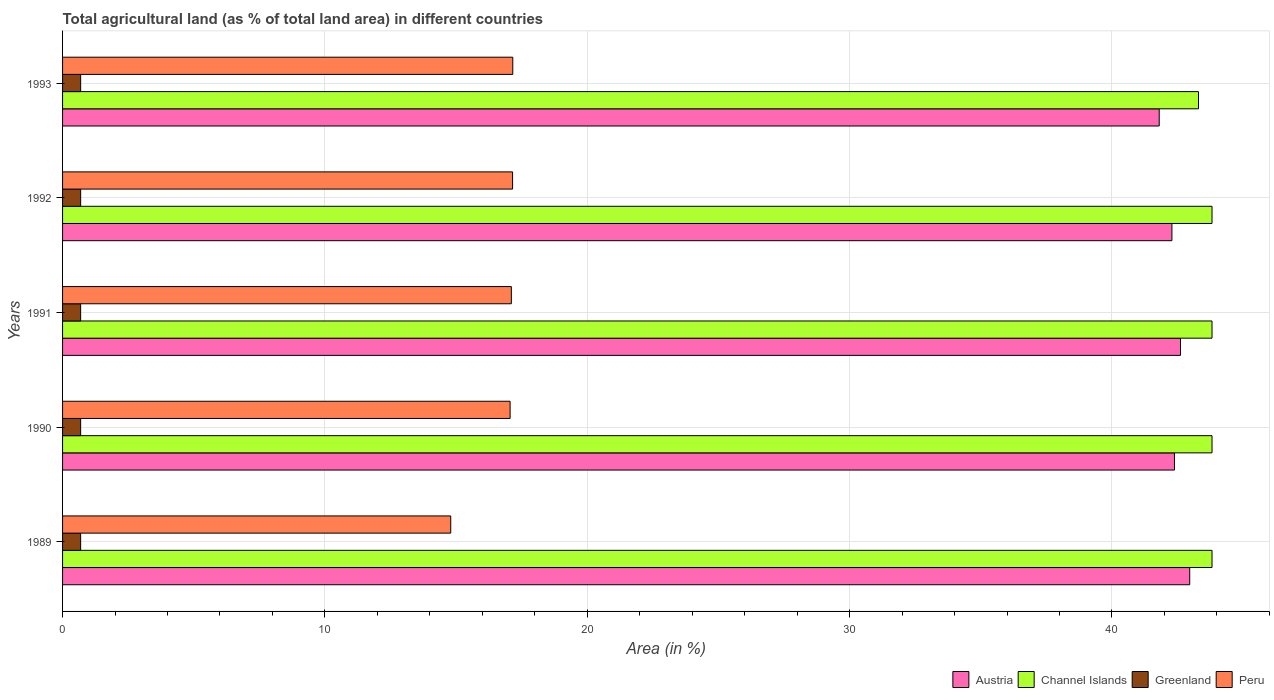How many different coloured bars are there?
Offer a very short reply. 4. How many bars are there on the 3rd tick from the top?
Your answer should be very brief. 4. What is the label of the 4th group of bars from the top?
Provide a short and direct response. 1990. What is the percentage of agricultural land in Austria in 1990?
Your answer should be compact. 42.38. Across all years, what is the maximum percentage of agricultural land in Peru?
Keep it short and to the point. 17.16. Across all years, what is the minimum percentage of agricultural land in Greenland?
Your answer should be very brief. 0.69. In which year was the percentage of agricultural land in Peru minimum?
Provide a short and direct response. 1989. What is the total percentage of agricultural land in Greenland in the graph?
Your answer should be very brief. 3.45. What is the difference between the percentage of agricultural land in Austria in 1991 and that in 1993?
Ensure brevity in your answer.  0.81. What is the difference between the percentage of agricultural land in Greenland in 1990 and the percentage of agricultural land in Austria in 1989?
Offer a terse response. -42.28. What is the average percentage of agricultural land in Greenland per year?
Your answer should be compact. 0.69. In the year 1991, what is the difference between the percentage of agricultural land in Austria and percentage of agricultural land in Channel Islands?
Make the answer very short. -1.2. What is the ratio of the percentage of agricultural land in Greenland in 1991 to that in 1992?
Your response must be concise. 1. What is the difference between the highest and the second highest percentage of agricultural land in Austria?
Keep it short and to the point. 0.35. What is the difference between the highest and the lowest percentage of agricultural land in Channel Islands?
Give a very brief answer. 0.52. Is the sum of the percentage of agricultural land in Austria in 1989 and 1990 greater than the maximum percentage of agricultural land in Peru across all years?
Make the answer very short. Yes. What does the 3rd bar from the top in 1993 represents?
Your response must be concise. Channel Islands. What does the 1st bar from the bottom in 1993 represents?
Your answer should be compact. Austria. Is it the case that in every year, the sum of the percentage of agricultural land in Channel Islands and percentage of agricultural land in Greenland is greater than the percentage of agricultural land in Peru?
Your answer should be compact. Yes. How many bars are there?
Your answer should be compact. 20. How many years are there in the graph?
Your answer should be very brief. 5. Does the graph contain any zero values?
Your answer should be compact. No. Does the graph contain grids?
Your response must be concise. Yes. How many legend labels are there?
Provide a short and direct response. 4. How are the legend labels stacked?
Provide a short and direct response. Horizontal. What is the title of the graph?
Your answer should be compact. Total agricultural land (as % of total land area) in different countries. What is the label or title of the X-axis?
Offer a terse response. Area (in %). What is the label or title of the Y-axis?
Offer a terse response. Years. What is the Area (in %) of Austria in 1989?
Provide a succinct answer. 42.96. What is the Area (in %) of Channel Islands in 1989?
Your response must be concise. 43.81. What is the Area (in %) of Greenland in 1989?
Make the answer very short. 0.69. What is the Area (in %) of Peru in 1989?
Provide a succinct answer. 14.8. What is the Area (in %) of Austria in 1990?
Keep it short and to the point. 42.38. What is the Area (in %) of Channel Islands in 1990?
Give a very brief answer. 43.81. What is the Area (in %) in Greenland in 1990?
Your answer should be very brief. 0.69. What is the Area (in %) in Peru in 1990?
Make the answer very short. 17.06. What is the Area (in %) in Austria in 1991?
Keep it short and to the point. 42.61. What is the Area (in %) in Channel Islands in 1991?
Give a very brief answer. 43.81. What is the Area (in %) of Greenland in 1991?
Keep it short and to the point. 0.69. What is the Area (in %) of Peru in 1991?
Offer a terse response. 17.11. What is the Area (in %) of Austria in 1992?
Keep it short and to the point. 42.29. What is the Area (in %) of Channel Islands in 1992?
Your answer should be compact. 43.81. What is the Area (in %) in Greenland in 1992?
Provide a short and direct response. 0.69. What is the Area (in %) of Peru in 1992?
Your answer should be very brief. 17.15. What is the Area (in %) of Austria in 1993?
Offer a terse response. 41.8. What is the Area (in %) in Channel Islands in 1993?
Provide a short and direct response. 43.3. What is the Area (in %) in Greenland in 1993?
Offer a terse response. 0.69. What is the Area (in %) in Peru in 1993?
Make the answer very short. 17.16. Across all years, what is the maximum Area (in %) of Austria?
Offer a terse response. 42.96. Across all years, what is the maximum Area (in %) of Channel Islands?
Give a very brief answer. 43.81. Across all years, what is the maximum Area (in %) of Greenland?
Give a very brief answer. 0.69. Across all years, what is the maximum Area (in %) of Peru?
Make the answer very short. 17.16. Across all years, what is the minimum Area (in %) in Austria?
Offer a very short reply. 41.8. Across all years, what is the minimum Area (in %) in Channel Islands?
Provide a succinct answer. 43.3. Across all years, what is the minimum Area (in %) of Greenland?
Ensure brevity in your answer.  0.69. Across all years, what is the minimum Area (in %) in Peru?
Offer a terse response. 14.8. What is the total Area (in %) in Austria in the graph?
Provide a short and direct response. 212.05. What is the total Area (in %) of Channel Islands in the graph?
Provide a succinct answer. 218.56. What is the total Area (in %) in Greenland in the graph?
Give a very brief answer. 3.45. What is the total Area (in %) of Peru in the graph?
Make the answer very short. 83.28. What is the difference between the Area (in %) in Austria in 1989 and that in 1990?
Ensure brevity in your answer.  0.58. What is the difference between the Area (in %) of Channel Islands in 1989 and that in 1990?
Keep it short and to the point. 0. What is the difference between the Area (in %) of Greenland in 1989 and that in 1990?
Give a very brief answer. -0. What is the difference between the Area (in %) in Peru in 1989 and that in 1990?
Offer a very short reply. -2.26. What is the difference between the Area (in %) of Austria in 1989 and that in 1991?
Offer a terse response. 0.35. What is the difference between the Area (in %) of Greenland in 1989 and that in 1991?
Ensure brevity in your answer.  -0. What is the difference between the Area (in %) of Peru in 1989 and that in 1991?
Your answer should be very brief. -2.31. What is the difference between the Area (in %) of Austria in 1989 and that in 1992?
Your response must be concise. 0.68. What is the difference between the Area (in %) in Greenland in 1989 and that in 1992?
Provide a short and direct response. -0. What is the difference between the Area (in %) of Peru in 1989 and that in 1992?
Your response must be concise. -2.36. What is the difference between the Area (in %) in Austria in 1989 and that in 1993?
Keep it short and to the point. 1.16. What is the difference between the Area (in %) in Channel Islands in 1989 and that in 1993?
Offer a very short reply. 0.52. What is the difference between the Area (in %) of Greenland in 1989 and that in 1993?
Make the answer very short. -0. What is the difference between the Area (in %) of Peru in 1989 and that in 1993?
Your response must be concise. -2.36. What is the difference between the Area (in %) in Austria in 1990 and that in 1991?
Your answer should be compact. -0.23. What is the difference between the Area (in %) of Peru in 1990 and that in 1991?
Provide a succinct answer. -0.05. What is the difference between the Area (in %) in Austria in 1990 and that in 1992?
Offer a terse response. 0.1. What is the difference between the Area (in %) in Channel Islands in 1990 and that in 1992?
Your answer should be very brief. 0. What is the difference between the Area (in %) of Greenland in 1990 and that in 1992?
Provide a short and direct response. -0. What is the difference between the Area (in %) in Peru in 1990 and that in 1992?
Offer a terse response. -0.09. What is the difference between the Area (in %) in Austria in 1990 and that in 1993?
Keep it short and to the point. 0.58. What is the difference between the Area (in %) in Channel Islands in 1990 and that in 1993?
Your response must be concise. 0.52. What is the difference between the Area (in %) of Greenland in 1990 and that in 1993?
Make the answer very short. -0. What is the difference between the Area (in %) of Peru in 1990 and that in 1993?
Make the answer very short. -0.1. What is the difference between the Area (in %) in Austria in 1991 and that in 1992?
Make the answer very short. 0.33. What is the difference between the Area (in %) in Greenland in 1991 and that in 1992?
Offer a very short reply. -0. What is the difference between the Area (in %) of Peru in 1991 and that in 1992?
Your answer should be very brief. -0.05. What is the difference between the Area (in %) of Austria in 1991 and that in 1993?
Your answer should be very brief. 0.81. What is the difference between the Area (in %) in Channel Islands in 1991 and that in 1993?
Provide a short and direct response. 0.52. What is the difference between the Area (in %) in Greenland in 1991 and that in 1993?
Provide a succinct answer. -0. What is the difference between the Area (in %) of Peru in 1991 and that in 1993?
Provide a short and direct response. -0.05. What is the difference between the Area (in %) in Austria in 1992 and that in 1993?
Offer a very short reply. 0.48. What is the difference between the Area (in %) in Channel Islands in 1992 and that in 1993?
Provide a succinct answer. 0.52. What is the difference between the Area (in %) of Greenland in 1992 and that in 1993?
Keep it short and to the point. 0. What is the difference between the Area (in %) in Peru in 1992 and that in 1993?
Offer a very short reply. -0.01. What is the difference between the Area (in %) in Austria in 1989 and the Area (in %) in Channel Islands in 1990?
Your answer should be compact. -0.85. What is the difference between the Area (in %) in Austria in 1989 and the Area (in %) in Greenland in 1990?
Offer a terse response. 42.28. What is the difference between the Area (in %) in Austria in 1989 and the Area (in %) in Peru in 1990?
Make the answer very short. 25.91. What is the difference between the Area (in %) of Channel Islands in 1989 and the Area (in %) of Greenland in 1990?
Make the answer very short. 43.13. What is the difference between the Area (in %) in Channel Islands in 1989 and the Area (in %) in Peru in 1990?
Keep it short and to the point. 26.76. What is the difference between the Area (in %) in Greenland in 1989 and the Area (in %) in Peru in 1990?
Offer a terse response. -16.37. What is the difference between the Area (in %) of Austria in 1989 and the Area (in %) of Channel Islands in 1991?
Ensure brevity in your answer.  -0.85. What is the difference between the Area (in %) of Austria in 1989 and the Area (in %) of Greenland in 1991?
Provide a succinct answer. 42.28. What is the difference between the Area (in %) of Austria in 1989 and the Area (in %) of Peru in 1991?
Your response must be concise. 25.86. What is the difference between the Area (in %) of Channel Islands in 1989 and the Area (in %) of Greenland in 1991?
Keep it short and to the point. 43.13. What is the difference between the Area (in %) in Channel Islands in 1989 and the Area (in %) in Peru in 1991?
Make the answer very short. 26.71. What is the difference between the Area (in %) of Greenland in 1989 and the Area (in %) of Peru in 1991?
Provide a short and direct response. -16.42. What is the difference between the Area (in %) of Austria in 1989 and the Area (in %) of Channel Islands in 1992?
Provide a succinct answer. -0.85. What is the difference between the Area (in %) of Austria in 1989 and the Area (in %) of Greenland in 1992?
Offer a terse response. 42.27. What is the difference between the Area (in %) in Austria in 1989 and the Area (in %) in Peru in 1992?
Your response must be concise. 25.81. What is the difference between the Area (in %) of Channel Islands in 1989 and the Area (in %) of Greenland in 1992?
Your response must be concise. 43.12. What is the difference between the Area (in %) of Channel Islands in 1989 and the Area (in %) of Peru in 1992?
Offer a very short reply. 26.66. What is the difference between the Area (in %) of Greenland in 1989 and the Area (in %) of Peru in 1992?
Your response must be concise. -16.46. What is the difference between the Area (in %) of Austria in 1989 and the Area (in %) of Channel Islands in 1993?
Offer a terse response. -0.33. What is the difference between the Area (in %) of Austria in 1989 and the Area (in %) of Greenland in 1993?
Provide a succinct answer. 42.27. What is the difference between the Area (in %) in Austria in 1989 and the Area (in %) in Peru in 1993?
Make the answer very short. 25.8. What is the difference between the Area (in %) in Channel Islands in 1989 and the Area (in %) in Greenland in 1993?
Provide a short and direct response. 43.12. What is the difference between the Area (in %) of Channel Islands in 1989 and the Area (in %) of Peru in 1993?
Your answer should be very brief. 26.65. What is the difference between the Area (in %) in Greenland in 1989 and the Area (in %) in Peru in 1993?
Give a very brief answer. -16.47. What is the difference between the Area (in %) of Austria in 1990 and the Area (in %) of Channel Islands in 1991?
Provide a succinct answer. -1.43. What is the difference between the Area (in %) in Austria in 1990 and the Area (in %) in Greenland in 1991?
Provide a succinct answer. 41.69. What is the difference between the Area (in %) in Austria in 1990 and the Area (in %) in Peru in 1991?
Give a very brief answer. 25.28. What is the difference between the Area (in %) in Channel Islands in 1990 and the Area (in %) in Greenland in 1991?
Ensure brevity in your answer.  43.13. What is the difference between the Area (in %) in Channel Islands in 1990 and the Area (in %) in Peru in 1991?
Your answer should be compact. 26.71. What is the difference between the Area (in %) in Greenland in 1990 and the Area (in %) in Peru in 1991?
Ensure brevity in your answer.  -16.42. What is the difference between the Area (in %) of Austria in 1990 and the Area (in %) of Channel Islands in 1992?
Ensure brevity in your answer.  -1.43. What is the difference between the Area (in %) of Austria in 1990 and the Area (in %) of Greenland in 1992?
Provide a succinct answer. 41.69. What is the difference between the Area (in %) of Austria in 1990 and the Area (in %) of Peru in 1992?
Keep it short and to the point. 25.23. What is the difference between the Area (in %) of Channel Islands in 1990 and the Area (in %) of Greenland in 1992?
Provide a short and direct response. 43.12. What is the difference between the Area (in %) in Channel Islands in 1990 and the Area (in %) in Peru in 1992?
Make the answer very short. 26.66. What is the difference between the Area (in %) of Greenland in 1990 and the Area (in %) of Peru in 1992?
Keep it short and to the point. -16.46. What is the difference between the Area (in %) in Austria in 1990 and the Area (in %) in Channel Islands in 1993?
Offer a terse response. -0.92. What is the difference between the Area (in %) in Austria in 1990 and the Area (in %) in Greenland in 1993?
Provide a succinct answer. 41.69. What is the difference between the Area (in %) of Austria in 1990 and the Area (in %) of Peru in 1993?
Keep it short and to the point. 25.22. What is the difference between the Area (in %) of Channel Islands in 1990 and the Area (in %) of Greenland in 1993?
Give a very brief answer. 43.12. What is the difference between the Area (in %) in Channel Islands in 1990 and the Area (in %) in Peru in 1993?
Make the answer very short. 26.65. What is the difference between the Area (in %) in Greenland in 1990 and the Area (in %) in Peru in 1993?
Your response must be concise. -16.47. What is the difference between the Area (in %) of Austria in 1991 and the Area (in %) of Channel Islands in 1992?
Your answer should be compact. -1.2. What is the difference between the Area (in %) of Austria in 1991 and the Area (in %) of Greenland in 1992?
Your answer should be very brief. 41.92. What is the difference between the Area (in %) in Austria in 1991 and the Area (in %) in Peru in 1992?
Make the answer very short. 25.46. What is the difference between the Area (in %) in Channel Islands in 1991 and the Area (in %) in Greenland in 1992?
Give a very brief answer. 43.12. What is the difference between the Area (in %) of Channel Islands in 1991 and the Area (in %) of Peru in 1992?
Your answer should be very brief. 26.66. What is the difference between the Area (in %) of Greenland in 1991 and the Area (in %) of Peru in 1992?
Offer a very short reply. -16.46. What is the difference between the Area (in %) of Austria in 1991 and the Area (in %) of Channel Islands in 1993?
Make the answer very short. -0.69. What is the difference between the Area (in %) in Austria in 1991 and the Area (in %) in Greenland in 1993?
Your answer should be very brief. 41.92. What is the difference between the Area (in %) of Austria in 1991 and the Area (in %) of Peru in 1993?
Provide a succinct answer. 25.45. What is the difference between the Area (in %) in Channel Islands in 1991 and the Area (in %) in Greenland in 1993?
Make the answer very short. 43.12. What is the difference between the Area (in %) of Channel Islands in 1991 and the Area (in %) of Peru in 1993?
Offer a very short reply. 26.65. What is the difference between the Area (in %) of Greenland in 1991 and the Area (in %) of Peru in 1993?
Your response must be concise. -16.47. What is the difference between the Area (in %) of Austria in 1992 and the Area (in %) of Channel Islands in 1993?
Offer a very short reply. -1.01. What is the difference between the Area (in %) of Austria in 1992 and the Area (in %) of Greenland in 1993?
Your answer should be compact. 41.6. What is the difference between the Area (in %) of Austria in 1992 and the Area (in %) of Peru in 1993?
Give a very brief answer. 25.13. What is the difference between the Area (in %) of Channel Islands in 1992 and the Area (in %) of Greenland in 1993?
Give a very brief answer. 43.12. What is the difference between the Area (in %) of Channel Islands in 1992 and the Area (in %) of Peru in 1993?
Your answer should be very brief. 26.65. What is the difference between the Area (in %) of Greenland in 1992 and the Area (in %) of Peru in 1993?
Give a very brief answer. -16.47. What is the average Area (in %) in Austria per year?
Give a very brief answer. 42.41. What is the average Area (in %) in Channel Islands per year?
Your answer should be compact. 43.71. What is the average Area (in %) in Greenland per year?
Your answer should be compact. 0.69. What is the average Area (in %) in Peru per year?
Keep it short and to the point. 16.66. In the year 1989, what is the difference between the Area (in %) in Austria and Area (in %) in Channel Islands?
Provide a succinct answer. -0.85. In the year 1989, what is the difference between the Area (in %) in Austria and Area (in %) in Greenland?
Offer a terse response. 42.28. In the year 1989, what is the difference between the Area (in %) in Austria and Area (in %) in Peru?
Your answer should be very brief. 28.17. In the year 1989, what is the difference between the Area (in %) of Channel Islands and Area (in %) of Greenland?
Keep it short and to the point. 43.13. In the year 1989, what is the difference between the Area (in %) in Channel Islands and Area (in %) in Peru?
Offer a very short reply. 29.02. In the year 1989, what is the difference between the Area (in %) of Greenland and Area (in %) of Peru?
Give a very brief answer. -14.11. In the year 1990, what is the difference between the Area (in %) of Austria and Area (in %) of Channel Islands?
Provide a succinct answer. -1.43. In the year 1990, what is the difference between the Area (in %) of Austria and Area (in %) of Greenland?
Your answer should be compact. 41.69. In the year 1990, what is the difference between the Area (in %) of Austria and Area (in %) of Peru?
Keep it short and to the point. 25.32. In the year 1990, what is the difference between the Area (in %) in Channel Islands and Area (in %) in Greenland?
Your answer should be very brief. 43.13. In the year 1990, what is the difference between the Area (in %) of Channel Islands and Area (in %) of Peru?
Offer a terse response. 26.76. In the year 1990, what is the difference between the Area (in %) in Greenland and Area (in %) in Peru?
Give a very brief answer. -16.37. In the year 1991, what is the difference between the Area (in %) in Austria and Area (in %) in Channel Islands?
Make the answer very short. -1.2. In the year 1991, what is the difference between the Area (in %) of Austria and Area (in %) of Greenland?
Offer a terse response. 41.92. In the year 1991, what is the difference between the Area (in %) in Austria and Area (in %) in Peru?
Keep it short and to the point. 25.51. In the year 1991, what is the difference between the Area (in %) in Channel Islands and Area (in %) in Greenland?
Keep it short and to the point. 43.13. In the year 1991, what is the difference between the Area (in %) in Channel Islands and Area (in %) in Peru?
Provide a succinct answer. 26.71. In the year 1991, what is the difference between the Area (in %) in Greenland and Area (in %) in Peru?
Keep it short and to the point. -16.42. In the year 1992, what is the difference between the Area (in %) in Austria and Area (in %) in Channel Islands?
Provide a succinct answer. -1.53. In the year 1992, what is the difference between the Area (in %) in Austria and Area (in %) in Greenland?
Ensure brevity in your answer.  41.6. In the year 1992, what is the difference between the Area (in %) in Austria and Area (in %) in Peru?
Give a very brief answer. 25.13. In the year 1992, what is the difference between the Area (in %) in Channel Islands and Area (in %) in Greenland?
Your answer should be very brief. 43.12. In the year 1992, what is the difference between the Area (in %) in Channel Islands and Area (in %) in Peru?
Your answer should be compact. 26.66. In the year 1992, what is the difference between the Area (in %) in Greenland and Area (in %) in Peru?
Provide a short and direct response. -16.46. In the year 1993, what is the difference between the Area (in %) in Austria and Area (in %) in Channel Islands?
Ensure brevity in your answer.  -1.5. In the year 1993, what is the difference between the Area (in %) in Austria and Area (in %) in Greenland?
Make the answer very short. 41.11. In the year 1993, what is the difference between the Area (in %) in Austria and Area (in %) in Peru?
Your response must be concise. 24.64. In the year 1993, what is the difference between the Area (in %) of Channel Islands and Area (in %) of Greenland?
Provide a succinct answer. 42.61. In the year 1993, what is the difference between the Area (in %) of Channel Islands and Area (in %) of Peru?
Give a very brief answer. 26.14. In the year 1993, what is the difference between the Area (in %) in Greenland and Area (in %) in Peru?
Ensure brevity in your answer.  -16.47. What is the ratio of the Area (in %) of Austria in 1989 to that in 1990?
Ensure brevity in your answer.  1.01. What is the ratio of the Area (in %) of Channel Islands in 1989 to that in 1990?
Give a very brief answer. 1. What is the ratio of the Area (in %) of Greenland in 1989 to that in 1990?
Provide a succinct answer. 1. What is the ratio of the Area (in %) in Peru in 1989 to that in 1990?
Give a very brief answer. 0.87. What is the ratio of the Area (in %) in Austria in 1989 to that in 1991?
Provide a succinct answer. 1.01. What is the ratio of the Area (in %) of Greenland in 1989 to that in 1991?
Your response must be concise. 1. What is the ratio of the Area (in %) of Peru in 1989 to that in 1991?
Offer a very short reply. 0.86. What is the ratio of the Area (in %) in Austria in 1989 to that in 1992?
Keep it short and to the point. 1.02. What is the ratio of the Area (in %) of Channel Islands in 1989 to that in 1992?
Give a very brief answer. 1. What is the ratio of the Area (in %) of Peru in 1989 to that in 1992?
Your answer should be very brief. 0.86. What is the ratio of the Area (in %) of Austria in 1989 to that in 1993?
Keep it short and to the point. 1.03. What is the ratio of the Area (in %) of Channel Islands in 1989 to that in 1993?
Your answer should be very brief. 1.01. What is the ratio of the Area (in %) in Greenland in 1989 to that in 1993?
Your answer should be very brief. 1. What is the ratio of the Area (in %) in Peru in 1989 to that in 1993?
Provide a short and direct response. 0.86. What is the ratio of the Area (in %) of Austria in 1990 to that in 1991?
Keep it short and to the point. 0.99. What is the ratio of the Area (in %) in Channel Islands in 1990 to that in 1991?
Your response must be concise. 1. What is the ratio of the Area (in %) of Greenland in 1990 to that in 1991?
Give a very brief answer. 1. What is the ratio of the Area (in %) of Peru in 1990 to that in 1991?
Provide a succinct answer. 1. What is the ratio of the Area (in %) of Channel Islands in 1990 to that in 1992?
Provide a succinct answer. 1. What is the ratio of the Area (in %) in Greenland in 1990 to that in 1992?
Offer a very short reply. 1. What is the ratio of the Area (in %) of Peru in 1990 to that in 1992?
Your response must be concise. 0.99. What is the ratio of the Area (in %) of Austria in 1990 to that in 1993?
Offer a terse response. 1.01. What is the ratio of the Area (in %) of Channel Islands in 1990 to that in 1993?
Your response must be concise. 1.01. What is the ratio of the Area (in %) of Austria in 1991 to that in 1992?
Your answer should be compact. 1.01. What is the ratio of the Area (in %) in Peru in 1991 to that in 1992?
Provide a short and direct response. 1. What is the ratio of the Area (in %) of Austria in 1991 to that in 1993?
Keep it short and to the point. 1.02. What is the ratio of the Area (in %) in Channel Islands in 1991 to that in 1993?
Give a very brief answer. 1.01. What is the ratio of the Area (in %) in Greenland in 1991 to that in 1993?
Offer a terse response. 1. What is the ratio of the Area (in %) in Peru in 1991 to that in 1993?
Ensure brevity in your answer.  1. What is the ratio of the Area (in %) in Austria in 1992 to that in 1993?
Your answer should be compact. 1.01. What is the ratio of the Area (in %) of Channel Islands in 1992 to that in 1993?
Provide a short and direct response. 1.01. What is the ratio of the Area (in %) of Greenland in 1992 to that in 1993?
Provide a short and direct response. 1. What is the difference between the highest and the second highest Area (in %) in Austria?
Give a very brief answer. 0.35. What is the difference between the highest and the second highest Area (in %) of Channel Islands?
Give a very brief answer. 0. What is the difference between the highest and the second highest Area (in %) in Peru?
Your answer should be compact. 0.01. What is the difference between the highest and the lowest Area (in %) in Austria?
Your answer should be compact. 1.16. What is the difference between the highest and the lowest Area (in %) in Channel Islands?
Ensure brevity in your answer.  0.52. What is the difference between the highest and the lowest Area (in %) in Greenland?
Offer a very short reply. 0. What is the difference between the highest and the lowest Area (in %) of Peru?
Give a very brief answer. 2.36. 